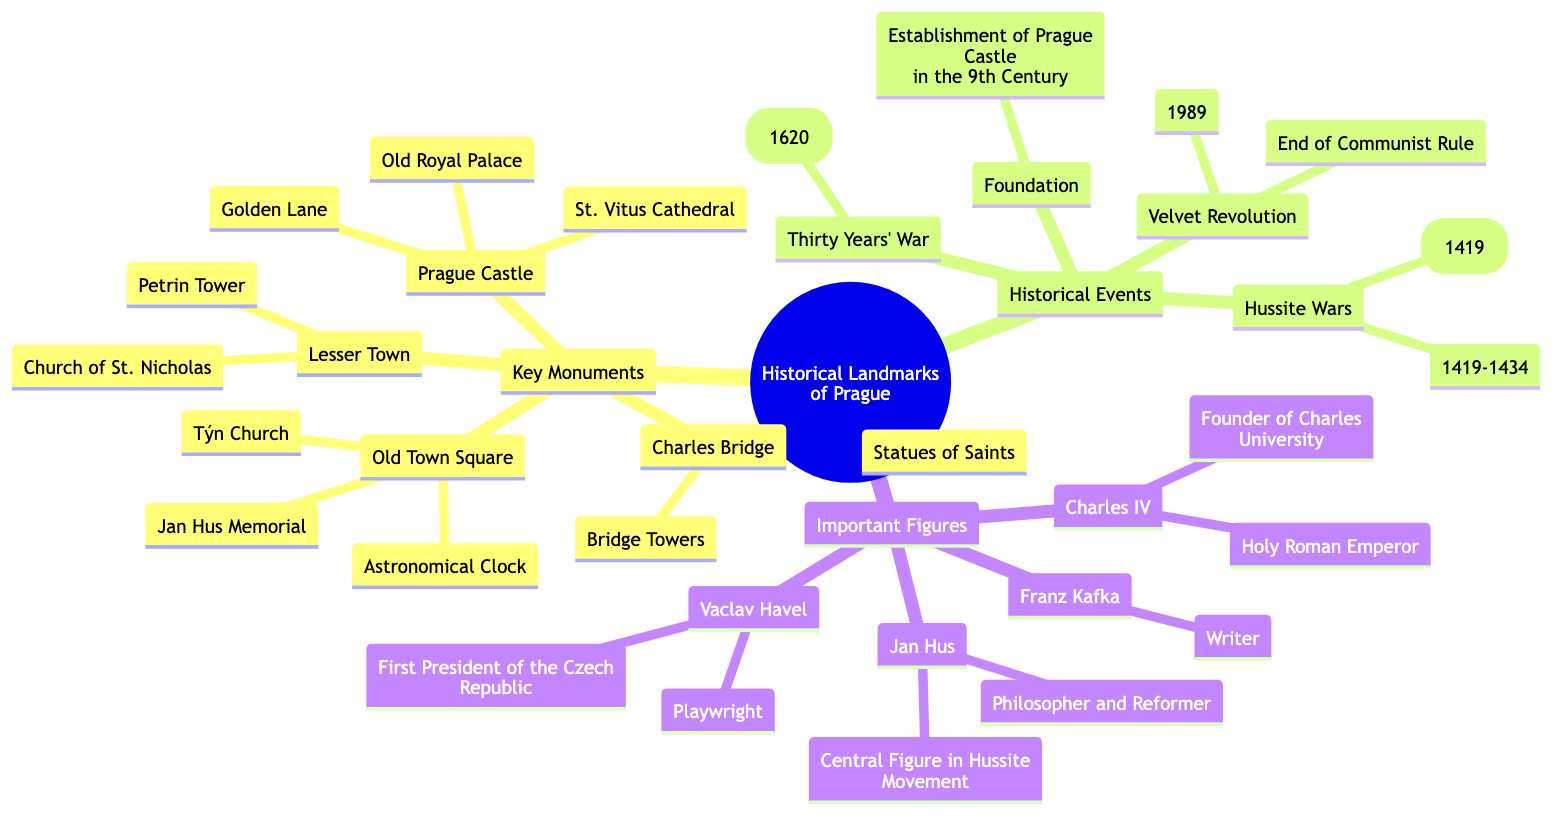What are the three key components of historical landmarks in Prague? The diagram's primary sections are "Key Monuments," "Historical Events," and "Important Figures." These represent the main categories under "Historical Landmarks of Prague."
Answer: Key Monuments, Historical Events, Important Figures How many key monuments are listed in the diagram? Under the "Key Monuments" section, there are four entries: Prague Castle, Charles Bridge, Old Town Square, and Lesser Town. Counting these provides the total.
Answer: 4 Which historical event occurred between 1419 and 1434? The diagram under the "Historical Events" section lists "Hussite Wars" with the dates 1419-1434. This involves the specific years mentioned in the question.
Answer: Hussite Wars What is the main figure associated with the establishment of Charles University? Looking under "Important Figures," Charles IV is noted as the founder of Charles University. This connects his identity to the specific educational institution.
Answer: Charles IV Which structure is located in the Old Town Square? The diagram lists three components under "Old Town Square," which includes the "Astronomical Clock," "Týn Church," and "Jan Hus Memorial." Any of these would be the answer, but for specificity, one will be chosen.
Answer: Astronomical Clock What major event marked the end of communist rule in Czechoslovakia? The diagram includes the "Velvet Revolution" within the section on Historical Events, linking it to the significant political change. The year 1989 is also indicated, which can indicate the endpoint of the event.
Answer: Velvet Revolution Name one monument found on Charles Bridge. Under the "Charles Bridge," the diagram lists two features: "Statues of Saints" and "Bridge Towers." Any one of these can be an accurate response to the question.
Answer: Statues of Saints Which important figure in Prague was a playwright? According to the "Important Figures" node, Vaclav Havel is identified as a playwright and also the first president of the Czech Republic. This specifically matches the question.
Answer: Vaclav Havel How many components are listed under the Lesser Town? The "Lesser Town" section includes two components: "Church of St. Nicholas" and "Petrin Tower." Adding these gives the total.
Answer: 2 